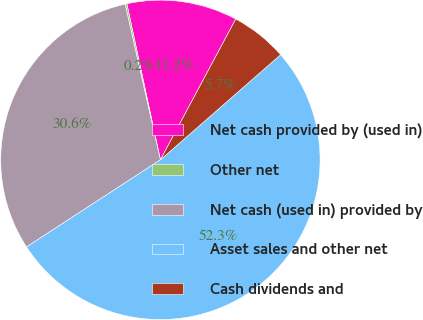<chart> <loc_0><loc_0><loc_500><loc_500><pie_chart><fcel>Net cash provided by (used in)<fcel>Other net<fcel>Net cash (used in) provided by<fcel>Asset sales and other net<fcel>Cash dividends and<nl><fcel>11.19%<fcel>0.18%<fcel>30.63%<fcel>52.26%<fcel>5.74%<nl></chart> 